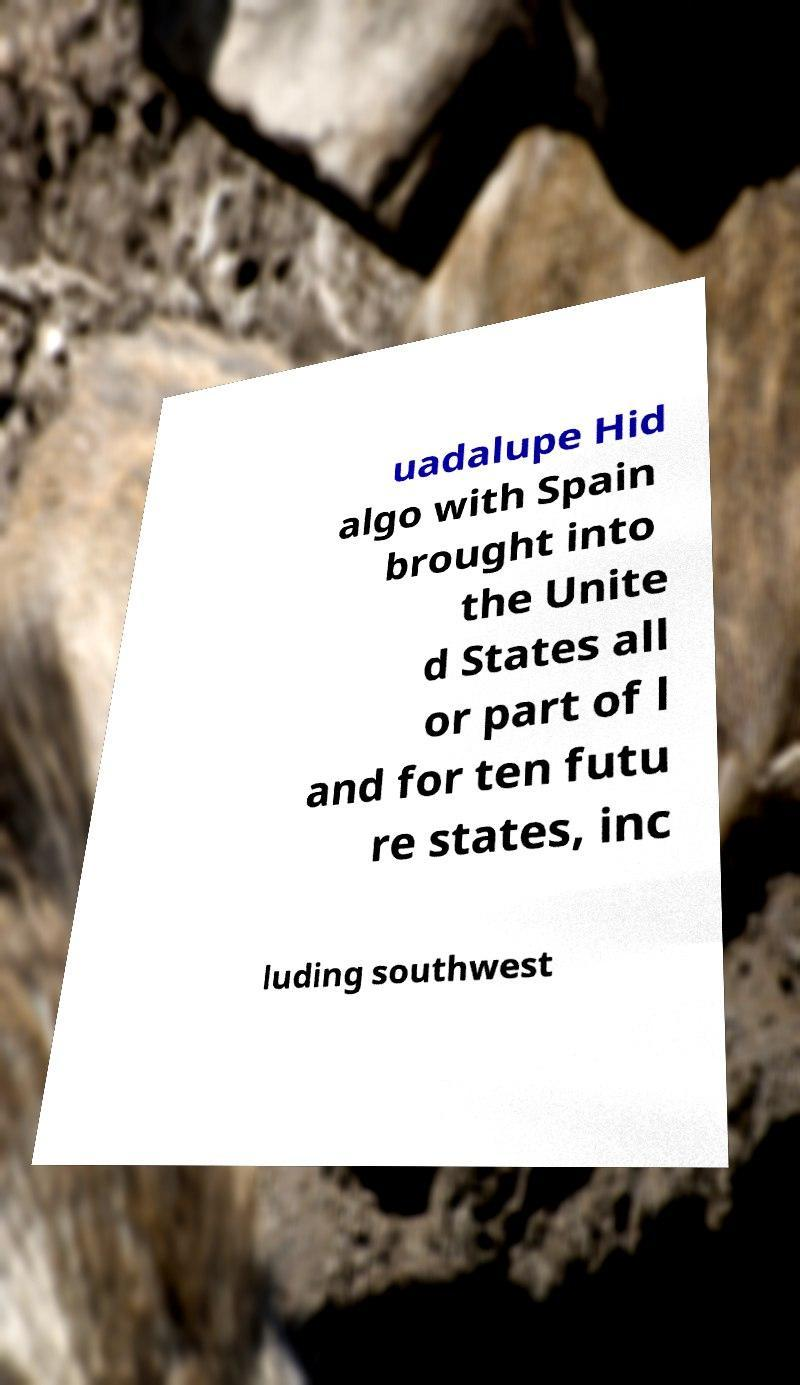Can you read and provide the text displayed in the image?This photo seems to have some interesting text. Can you extract and type it out for me? uadalupe Hid algo with Spain brought into the Unite d States all or part of l and for ten futu re states, inc luding southwest 